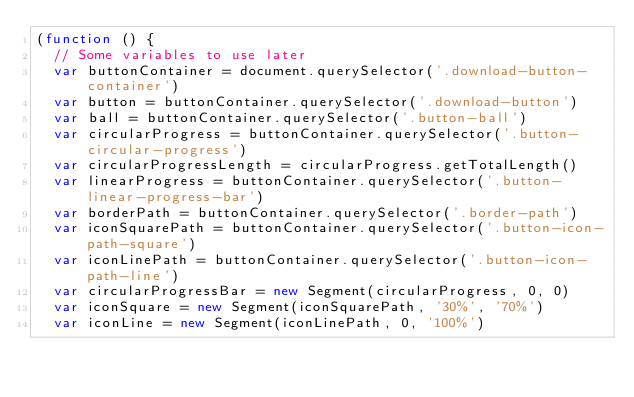Convert code to text. <code><loc_0><loc_0><loc_500><loc_500><_JavaScript_>(function () {
  // Some variables to use later
  var buttonContainer = document.querySelector('.download-button-container')
  var button = buttonContainer.querySelector('.download-button')
  var ball = buttonContainer.querySelector('.button-ball')
  var circularProgress = buttonContainer.querySelector('.button-circular-progress')
  var circularProgressLength = circularProgress.getTotalLength()
  var linearProgress = buttonContainer.querySelector('.button-linear-progress-bar')
  var borderPath = buttonContainer.querySelector('.border-path')
  var iconSquarePath = buttonContainer.querySelector('.button-icon-path-square')
  var iconLinePath = buttonContainer.querySelector('.button-icon-path-line')
  var circularProgressBar = new Segment(circularProgress, 0, 0)
  var iconSquare = new Segment(iconSquarePath, '30%', '70%')
  var iconLine = new Segment(iconLinePath, 0, '100%')</code> 